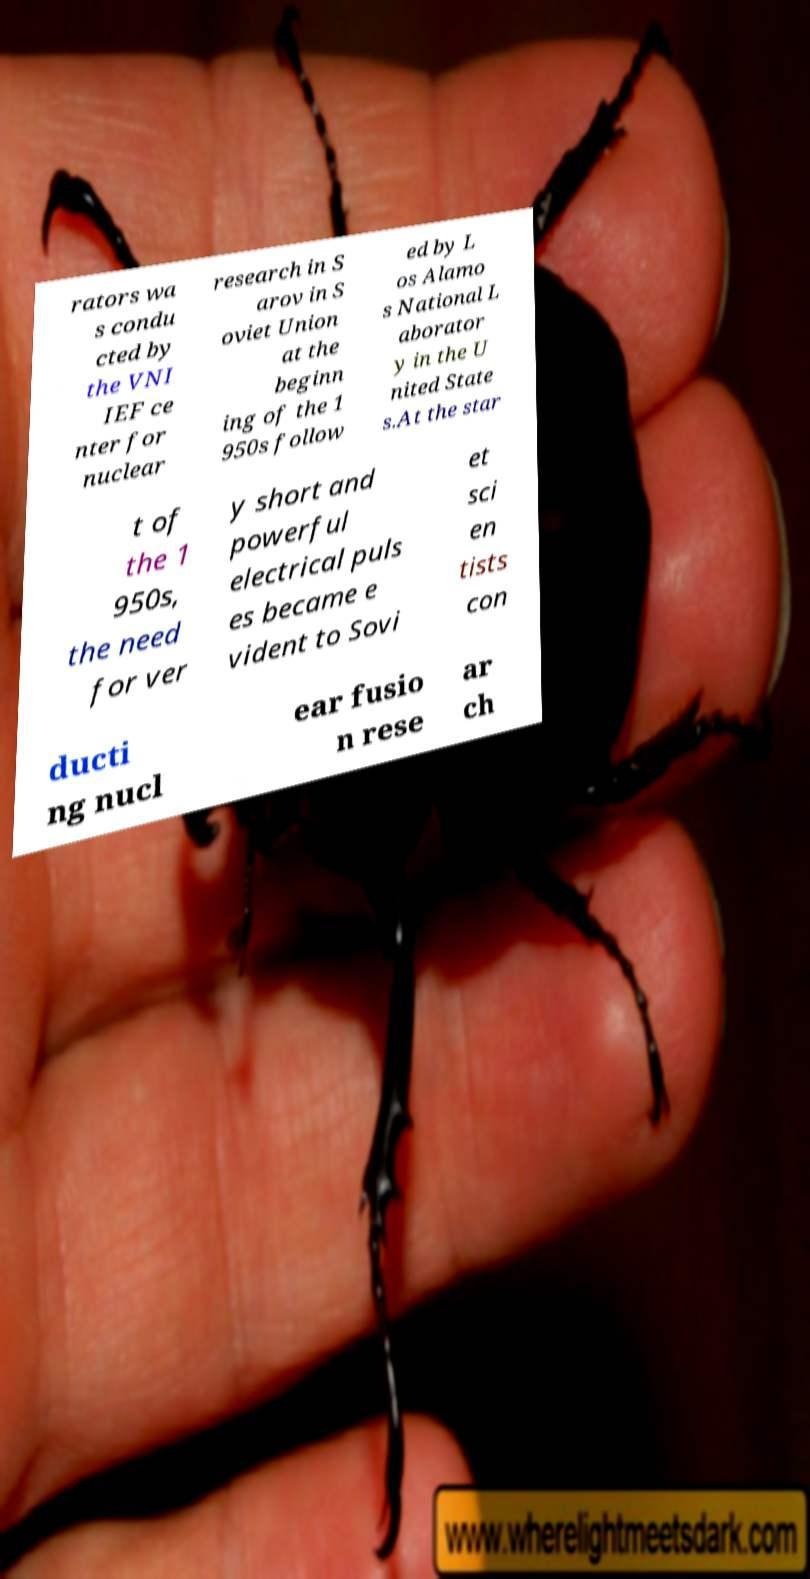There's text embedded in this image that I need extracted. Can you transcribe it verbatim? rators wa s condu cted by the VNI IEF ce nter for nuclear research in S arov in S oviet Union at the beginn ing of the 1 950s follow ed by L os Alamo s National L aborator y in the U nited State s.At the star t of the 1 950s, the need for ver y short and powerful electrical puls es became e vident to Sovi et sci en tists con ducti ng nucl ear fusio n rese ar ch 